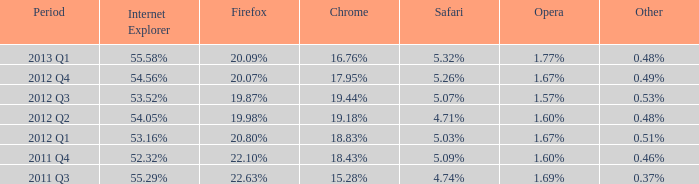Which version of internet explorer had a 1.67% market share, similar to opera, during the first quarter of 2012? 53.16%. 